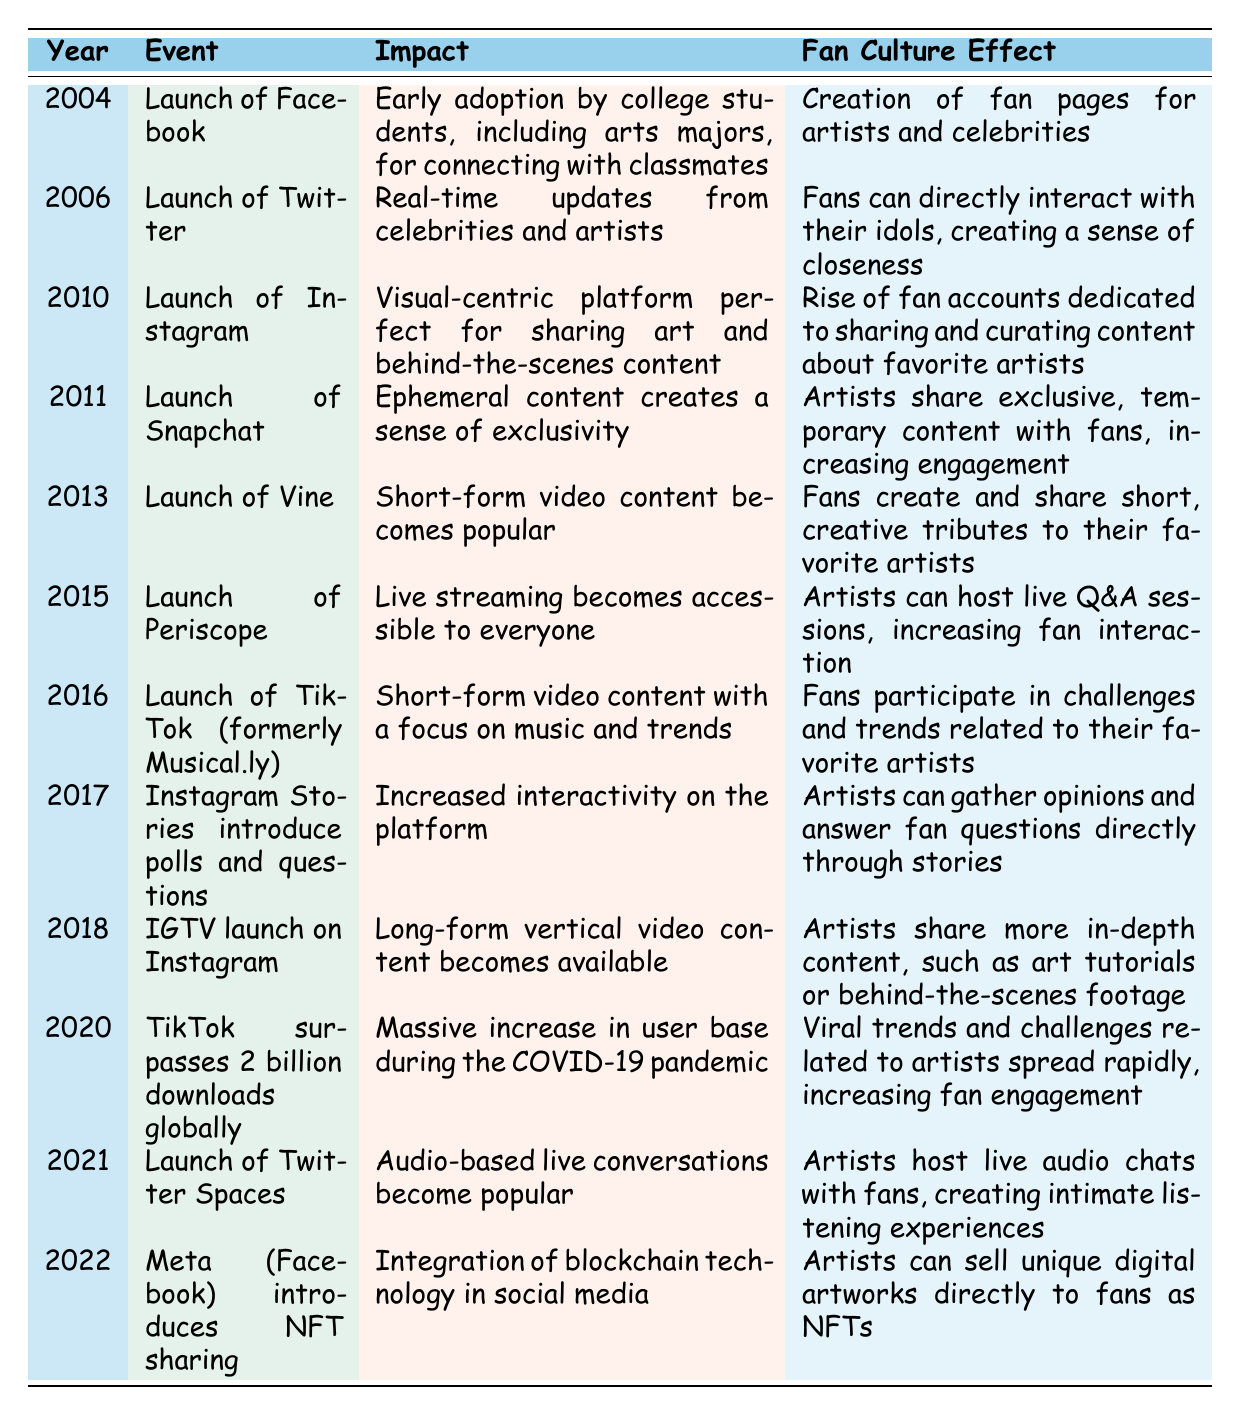What year was Facebook launched? According to the table, Facebook was launched in the year 2004 as indicated in the first row.
Answer: 2004 What impact did the launch of Twitter have? The launch of Twitter in 2006 had the impact of providing real-time updates from celebrities and artists, as shown in the second row of the table.
Answer: Real-time updates from celebrities and artists Which social media platform introduced polls and questions in 2017? The introduction of polls and questions in 2017 was part of Instagram Stories, mentioned in the row for that year.
Answer: Instagram Stories True or False: TikTok surpassed 2 billion downloads before the launch of Twitter Spaces. By checking the years listed in the table, TikTok surpassed 2 billion downloads globally in 2020, while Twitter Spaces was launched in 2021. Therefore, the statement is true.
Answer: True What are the significant events related to the rise of fan culture between 2010 and 2015? Looking at the years from 2010 to 2015, the launch of Instagram (2010) encouraged fans to create dedicated accounts, while Periscope (2015) allowed artists to host live Q&A sessions—both contributing significantly to fan culture.
Answer: Instagram and Periscope List the fan culture effects associated with the launches of Snapchat and Vine. From the rows for Snapchat (2011) and Vine (2013), Snapchat allowed artists to share exclusive temporary content, while Vine enabled fans to create and share short tributes to their favorite artists.
Answer: Exclusive content on Snapchat; Short tributes on Vine How many social media platforms were launched after 2015? By examining the table, the platforms launched after 2015 are Instagram Stories (2017), IGTV (2018), TikTok (2016), Twitter Spaces (2021), and NFT sharing by Meta (2022). This makes a total of 5 platforms launched after 2015.
Answer: 5 What was the effect of TikTok's popularity surge during the COVID-19 pandemic? The table indicates that TikTok's surpassing 2 billion downloads during the COVID-19 pandemic led to viral trends and challenges that increased fan engagement significantly, as seen in the 2020 row.
Answer: Increased fan engagement through viral trends Which platform allowed the selling of unique digital artworks as NFTs? Meta (Facebook) introduced NFT sharing in 2022, allowing artists to sell unique digital artworks to fans, as stated in the last row of the table.
Answer: Meta (Facebook) 